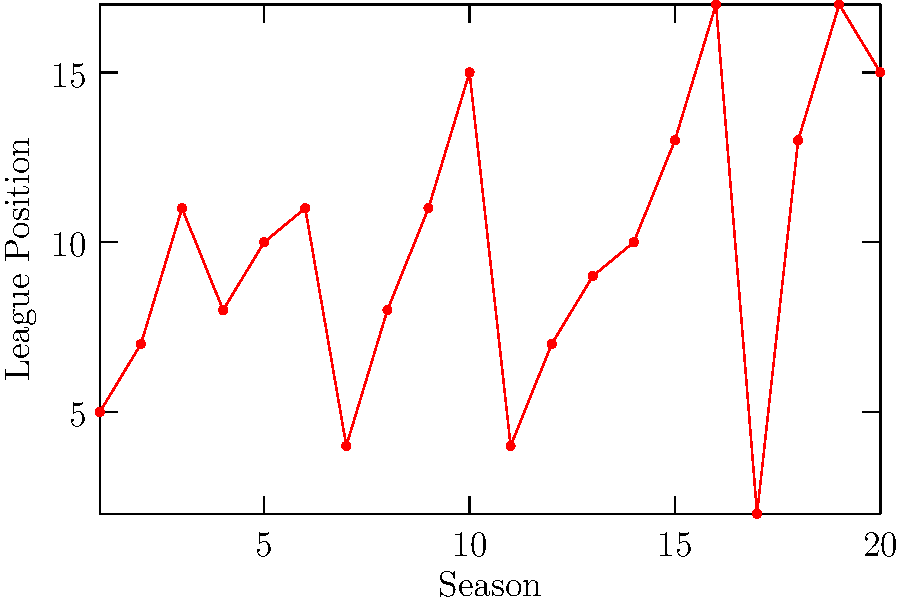Based on the line graph showing Hannover 96's league positions over the past 20 seasons, in which season did the team achieve its highest league position, and what was that position? To answer this question, we need to analyze the line graph carefully:

1. The x-axis represents the seasons (1-20), while the y-axis shows the league positions (lower numbers indicate higher positions).

2. We need to find the lowest point on the graph, as this represents the highest league position.

3. Scanning the graph from left to right, we can see that the line reaches its lowest point at season 17.

4. At season 17, the position appears to be 2, which is the highest (best) position shown on the graph.

5. This means that in the 17th season of the 20-season period, Hannover 96 achieved its best league performance, finishing in 2nd place.
Answer: Season 17, 2nd place 